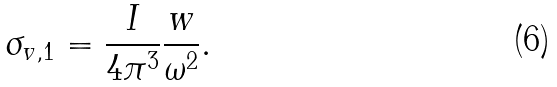<formula> <loc_0><loc_0><loc_500><loc_500>\sigma _ { v , 1 } = \frac { I } { 4 \pi ^ { 3 } } \frac { w } { \omega ^ { 2 } } .</formula> 